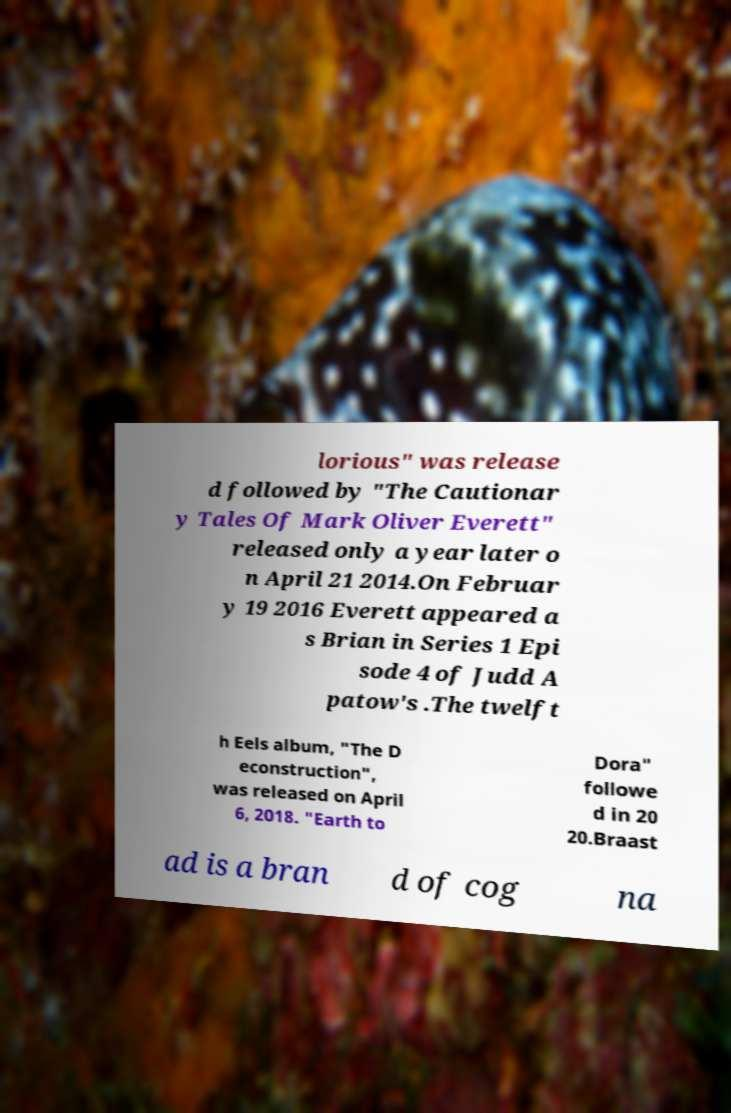What messages or text are displayed in this image? I need them in a readable, typed format. lorious" was release d followed by "The Cautionar y Tales Of Mark Oliver Everett" released only a year later o n April 21 2014.On Februar y 19 2016 Everett appeared a s Brian in Series 1 Epi sode 4 of Judd A patow's .The twelft h Eels album, "The D econstruction", was released on April 6, 2018. "Earth to Dora" followe d in 20 20.Braast ad is a bran d of cog na 